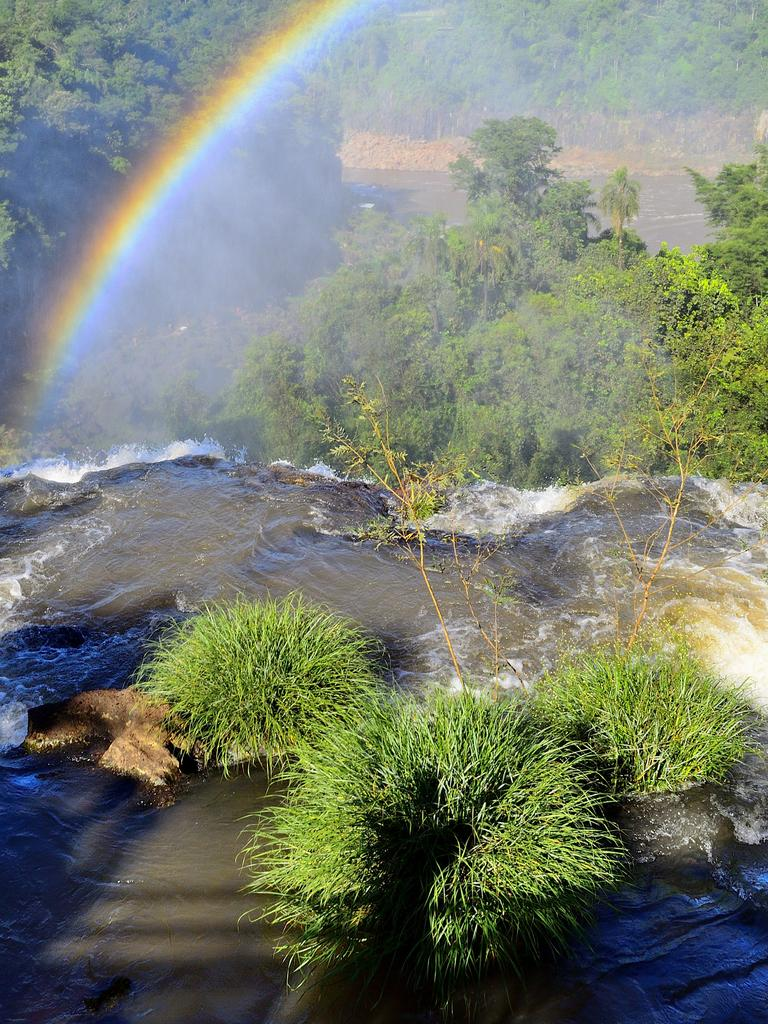What types of vegetation can be seen in the foreground of the picture? There are shrubs and a plant in the foreground of the picture. What is visible in the foreground of the picture besides vegetation? There is water visible in the foreground of the picture. What can be seen in the center of the picture? There are trees, a water body, and a rainbow in the center of the picture. What types of vegetation can be seen at the top of the picture? There are trees at the top of the picture. What type of mine can be seen in the picture? There is no mine present in the picture. Can you describe the kick of the rainbow in the picture? There is no kick present in the picture; it is a rainbow, which is a natural atmospheric phenomenon. 